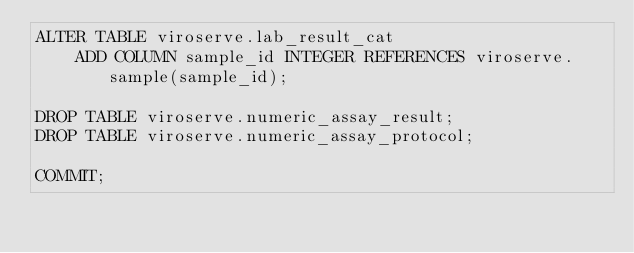Convert code to text. <code><loc_0><loc_0><loc_500><loc_500><_SQL_>ALTER TABLE viroserve.lab_result_cat
    ADD COLUMN sample_id INTEGER REFERENCES viroserve.sample(sample_id);

DROP TABLE viroserve.numeric_assay_result;
DROP TABLE viroserve.numeric_assay_protocol;

COMMIT;
</code> 